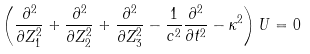Convert formula to latex. <formula><loc_0><loc_0><loc_500><loc_500>\left ( \frac { \partial ^ { 2 } } { \partial Z _ { 1 } ^ { 2 } } + \frac { \partial ^ { 2 } } { \partial Z _ { 2 } ^ { 2 } } + \frac { \partial ^ { 2 } } { \partial Z _ { 3 } ^ { 2 } } - \frac { 1 } { c ^ { 2 } } \frac { \partial ^ { 2 } } { \partial t ^ { 2 } } - \kappa ^ { 2 } \right ) U = 0</formula> 